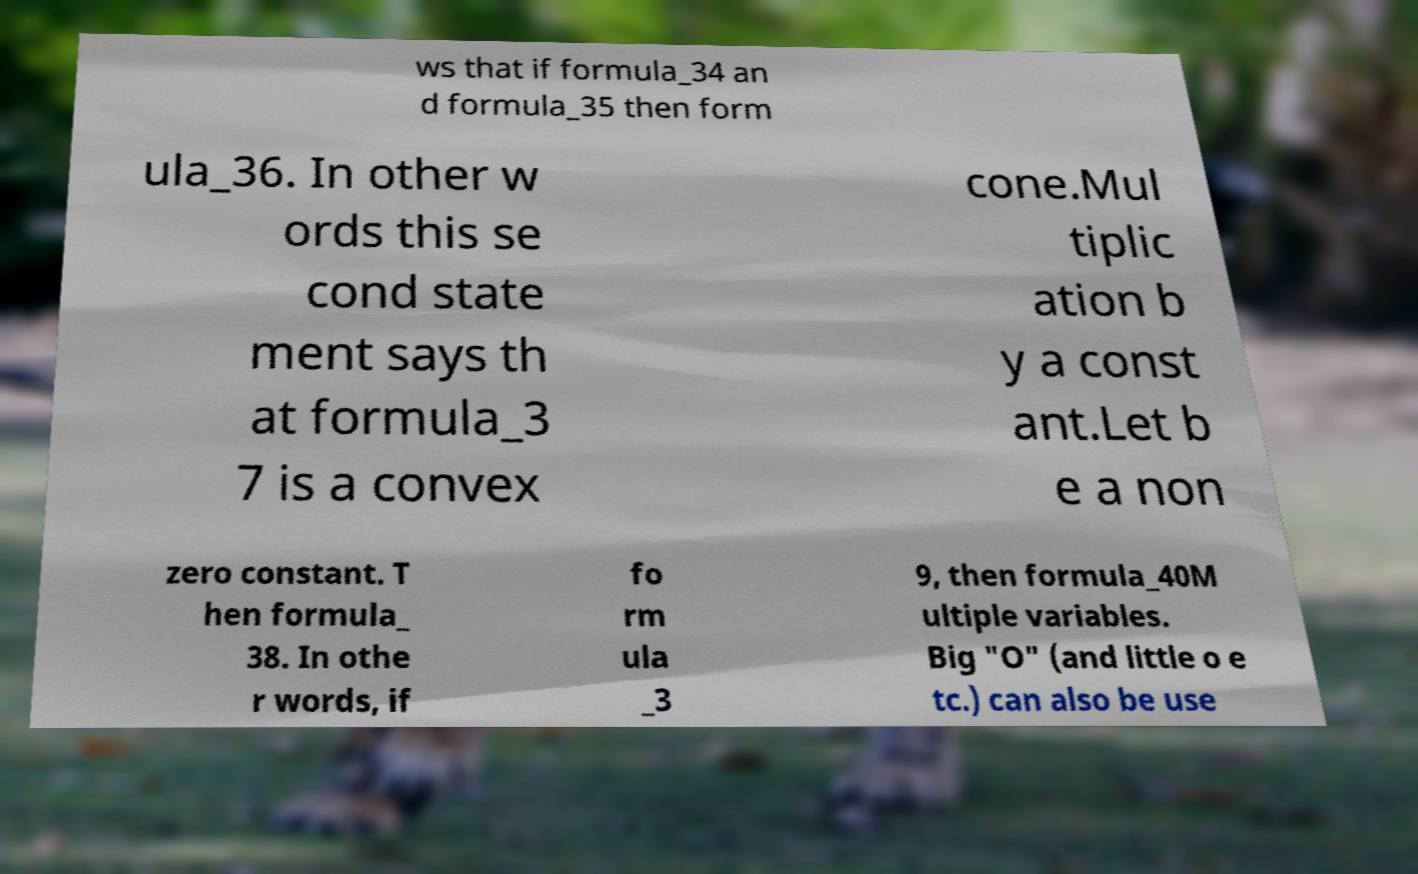Please identify and transcribe the text found in this image. ws that if formula_34 an d formula_35 then form ula_36. In other w ords this se cond state ment says th at formula_3 7 is a convex cone.Mul tiplic ation b y a const ant.Let b e a non zero constant. T hen formula_ 38. In othe r words, if fo rm ula _3 9, then formula_40M ultiple variables. Big "O" (and little o e tc.) can also be use 